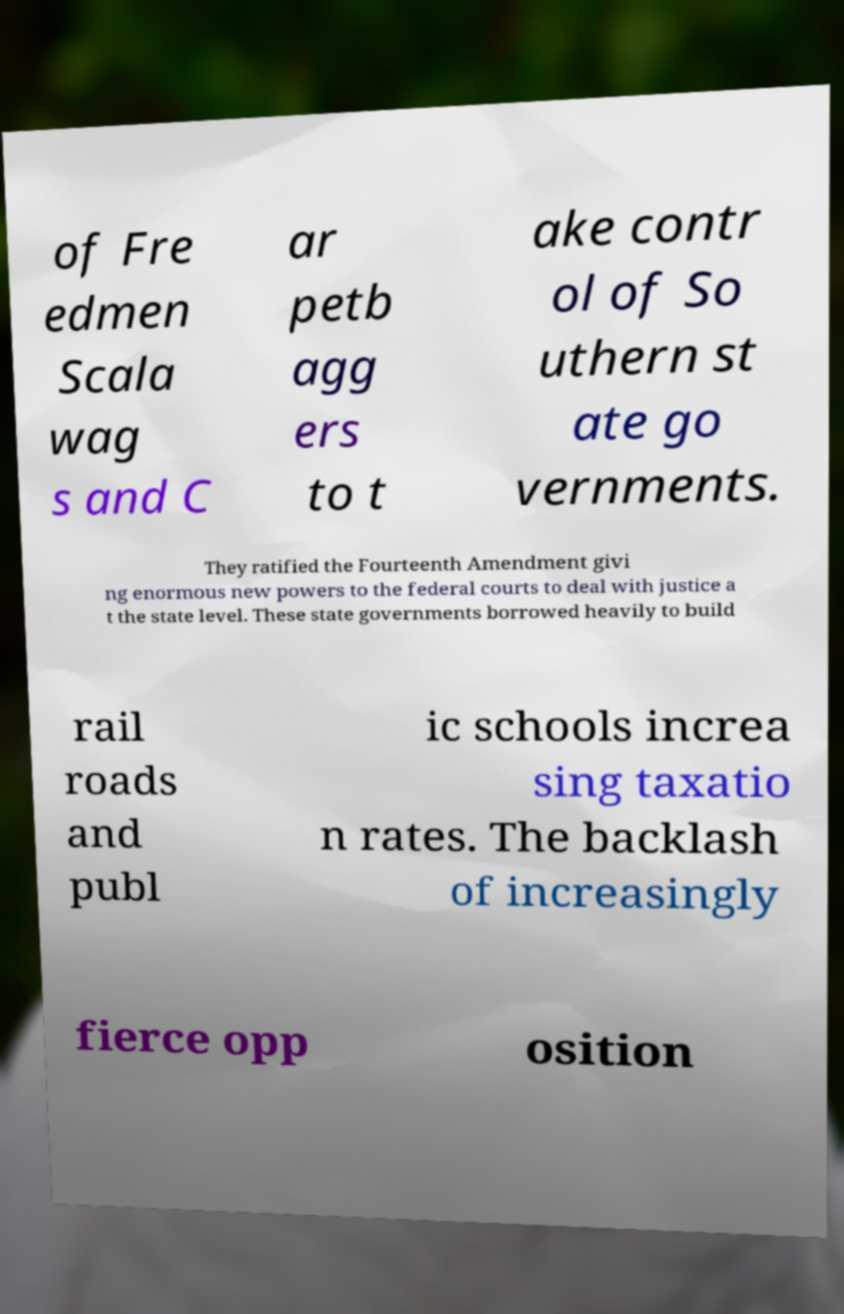What messages or text are displayed in this image? I need them in a readable, typed format. of Fre edmen Scala wag s and C ar petb agg ers to t ake contr ol of So uthern st ate go vernments. They ratified the Fourteenth Amendment givi ng enormous new powers to the federal courts to deal with justice a t the state level. These state governments borrowed heavily to build rail roads and publ ic schools increa sing taxatio n rates. The backlash of increasingly fierce opp osition 